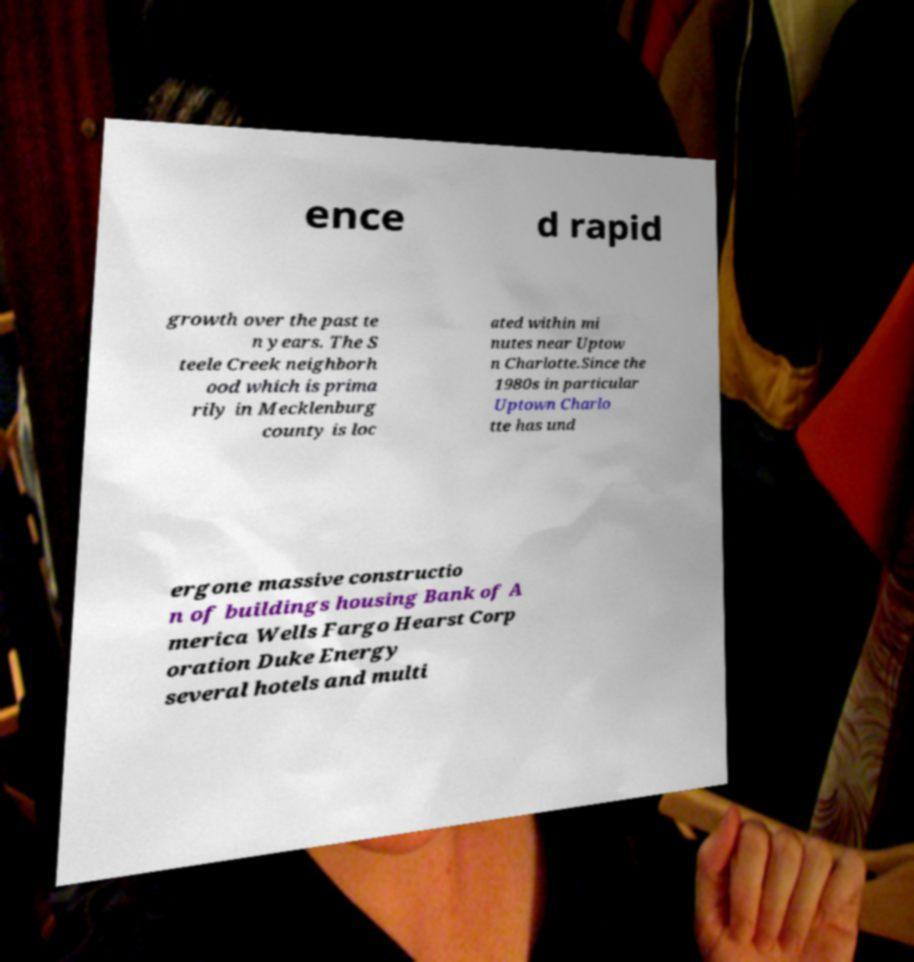There's text embedded in this image that I need extracted. Can you transcribe it verbatim? ence d rapid growth over the past te n years. The S teele Creek neighborh ood which is prima rily in Mecklenburg county is loc ated within mi nutes near Uptow n Charlotte.Since the 1980s in particular Uptown Charlo tte has und ergone massive constructio n of buildings housing Bank of A merica Wells Fargo Hearst Corp oration Duke Energy several hotels and multi 